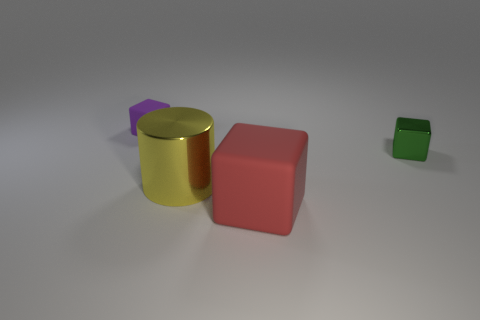Subtract all green cubes. How many cubes are left? 2 Subtract 1 cylinders. How many cylinders are left? 0 Add 3 small green objects. How many objects exist? 7 Subtract all purple cubes. How many cubes are left? 2 Subtract 0 green cylinders. How many objects are left? 4 Subtract all blocks. How many objects are left? 1 Subtract all red blocks. Subtract all purple cylinders. How many blocks are left? 2 Subtract all cyan balls. How many red cylinders are left? 0 Subtract all small shiny objects. Subtract all large gray metallic cylinders. How many objects are left? 3 Add 2 yellow cylinders. How many yellow cylinders are left? 3 